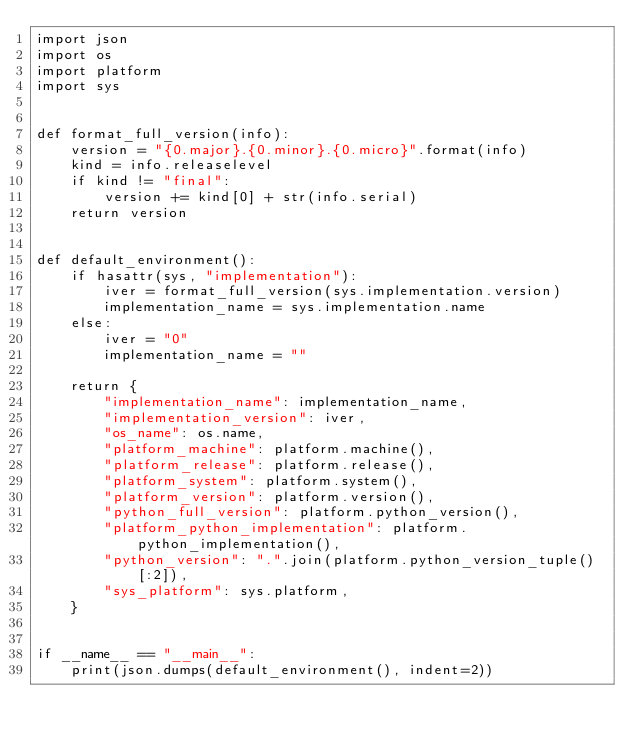<code> <loc_0><loc_0><loc_500><loc_500><_Python_>import json
import os
import platform
import sys


def format_full_version(info):
    version = "{0.major}.{0.minor}.{0.micro}".format(info)
    kind = info.releaselevel
    if kind != "final":
        version += kind[0] + str(info.serial)
    return version


def default_environment():
    if hasattr(sys, "implementation"):
        iver = format_full_version(sys.implementation.version)
        implementation_name = sys.implementation.name
    else:
        iver = "0"
        implementation_name = ""

    return {
        "implementation_name": implementation_name,
        "implementation_version": iver,
        "os_name": os.name,
        "platform_machine": platform.machine(),
        "platform_release": platform.release(),
        "platform_system": platform.system(),
        "platform_version": platform.version(),
        "python_full_version": platform.python_version(),
        "platform_python_implementation": platform.python_implementation(),
        "python_version": ".".join(platform.python_version_tuple()[:2]),
        "sys_platform": sys.platform,
    }


if __name__ == "__main__":
    print(json.dumps(default_environment(), indent=2))
</code> 